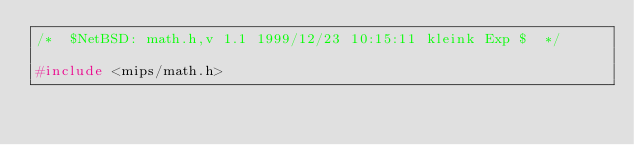<code> <loc_0><loc_0><loc_500><loc_500><_C_>/*	$NetBSD: math.h,v 1.1 1999/12/23 10:15:11 kleink Exp $	*/

#include <mips/math.h>
</code> 